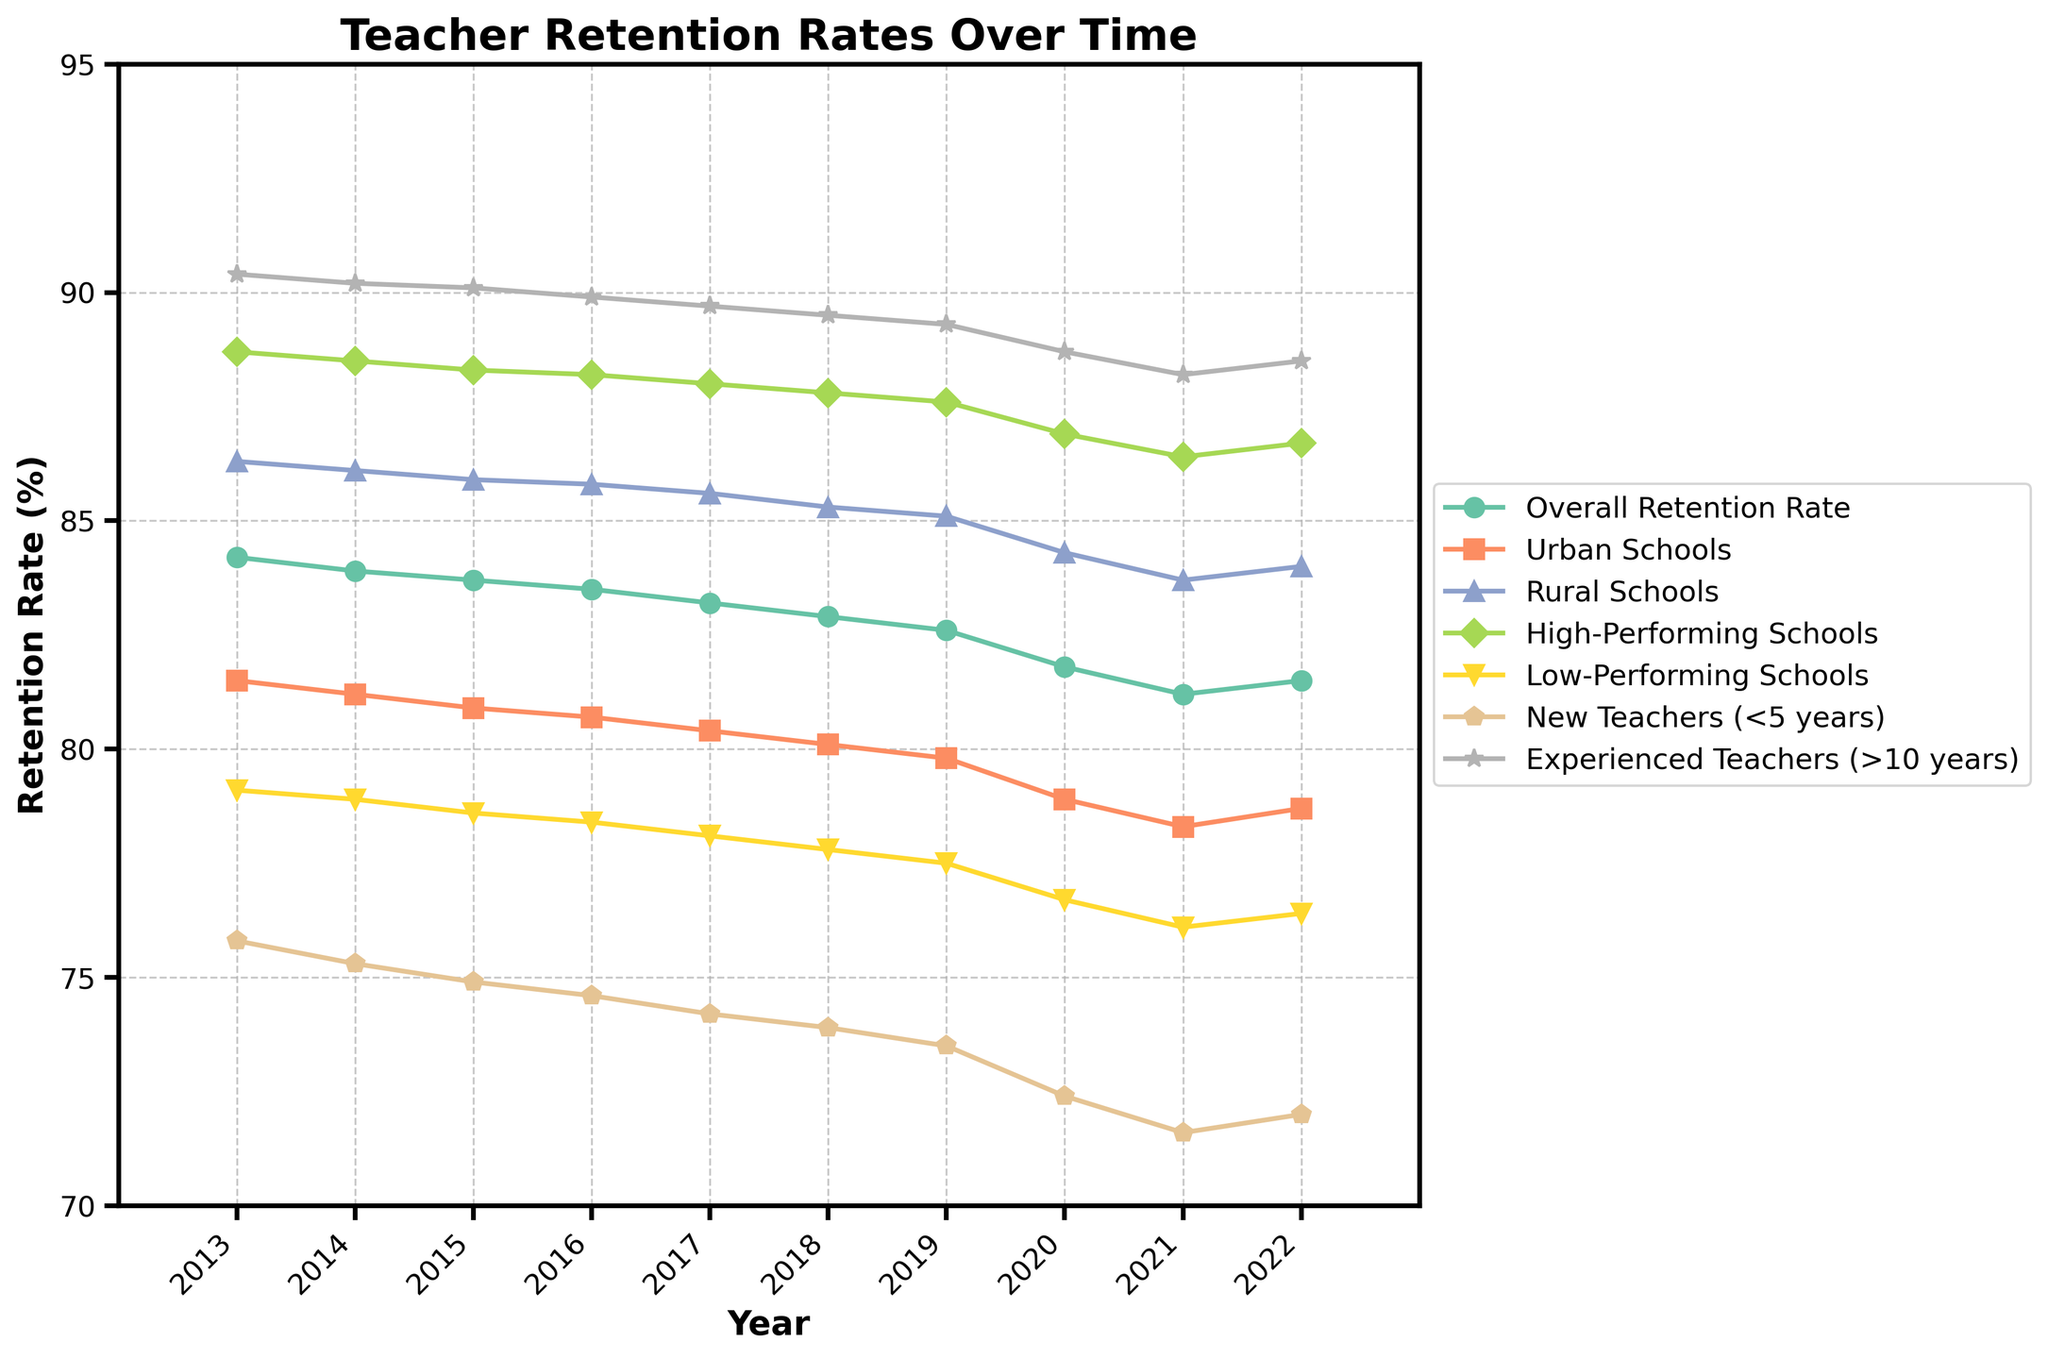What was the overall teacher retention rate in 2015? The overall teacher retention rate for each year is visible on the chart. For 2015, find the corresponding value on the "Overall Retention Rate" line.
Answer: 83.7% Which group had the highest retention rate in 2016? To find the highest retention rate in 2016, compare the values of all groups for that year. The "Experienced Teachers (>10 years)" line appears at the top in 2016.
Answer: Experienced Teachers (>10 years) How did the retention rate of urban schools change from 2013 to 2022? Check the "Urban Schools" line and note the values for 2013 and 2022. Calculate the difference between these two values.
Answer: Decreased by 2.8% Which year had the lowest retention rate for new teachers (<5 years)? Look for the minimum point on the "New Teachers (<5 years)" line and identify the year associated with this point.
Answer: 2021 Was there a notable difference in retention rates between high-performing and low-performing schools in 2020? Compare the retention rates of "High-Performing Schools" and "Low-Performing Schools" lines in 2020. Subtract to find the difference.
Answer: Yes, 10.2% What is the average retention rate for rural schools over the decade? Sum the yearly retention rates for "Rural Schools" from 2013 to 2022, then divide by the number of years (10).
Answer: 85.1% How does the retention rate for experienced teachers (>10 years) compare to the overall retention rate in 2022? Locate the values for "Experienced Teachers (>10 years)" and "Overall Retention Rate" in 2022. Compare the two values directly.
Answer: Higher Which category showed the most consistent retention rate over the years? Examine the variation in lines. The smallest fluctuation indicates consistency. "Experienced Teachers (>10 years)" varies the least.
Answer: Experienced Teachers (>10 years) In what year did low-performing schools have the most significant drop in retention rate? Identify the steepest decline in the "Low-Performing Schools" line. Measure the year of the greatest drop.
Answer: 2020 If you were to rank the retention rates of urban, rural, high-performing, and low-performing schools in 2019, what would the order be from highest to lowest? Compare the values for these categories in 2019 and sort them descendingly.
Answer: High-Performing, Rural, Urban, Low-Performing 